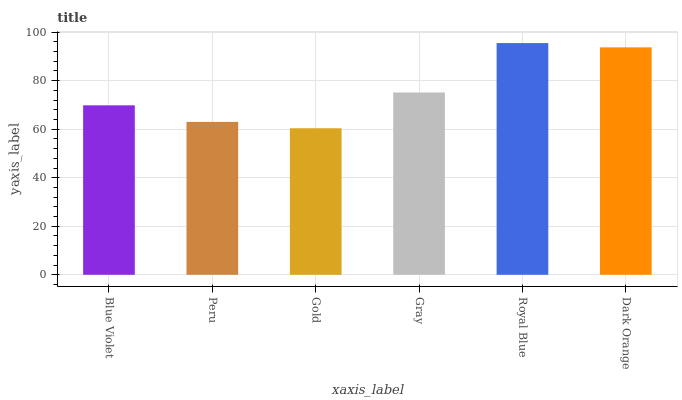Is Gold the minimum?
Answer yes or no. Yes. Is Royal Blue the maximum?
Answer yes or no. Yes. Is Peru the minimum?
Answer yes or no. No. Is Peru the maximum?
Answer yes or no. No. Is Blue Violet greater than Peru?
Answer yes or no. Yes. Is Peru less than Blue Violet?
Answer yes or no. Yes. Is Peru greater than Blue Violet?
Answer yes or no. No. Is Blue Violet less than Peru?
Answer yes or no. No. Is Gray the high median?
Answer yes or no. Yes. Is Blue Violet the low median?
Answer yes or no. Yes. Is Gold the high median?
Answer yes or no. No. Is Dark Orange the low median?
Answer yes or no. No. 